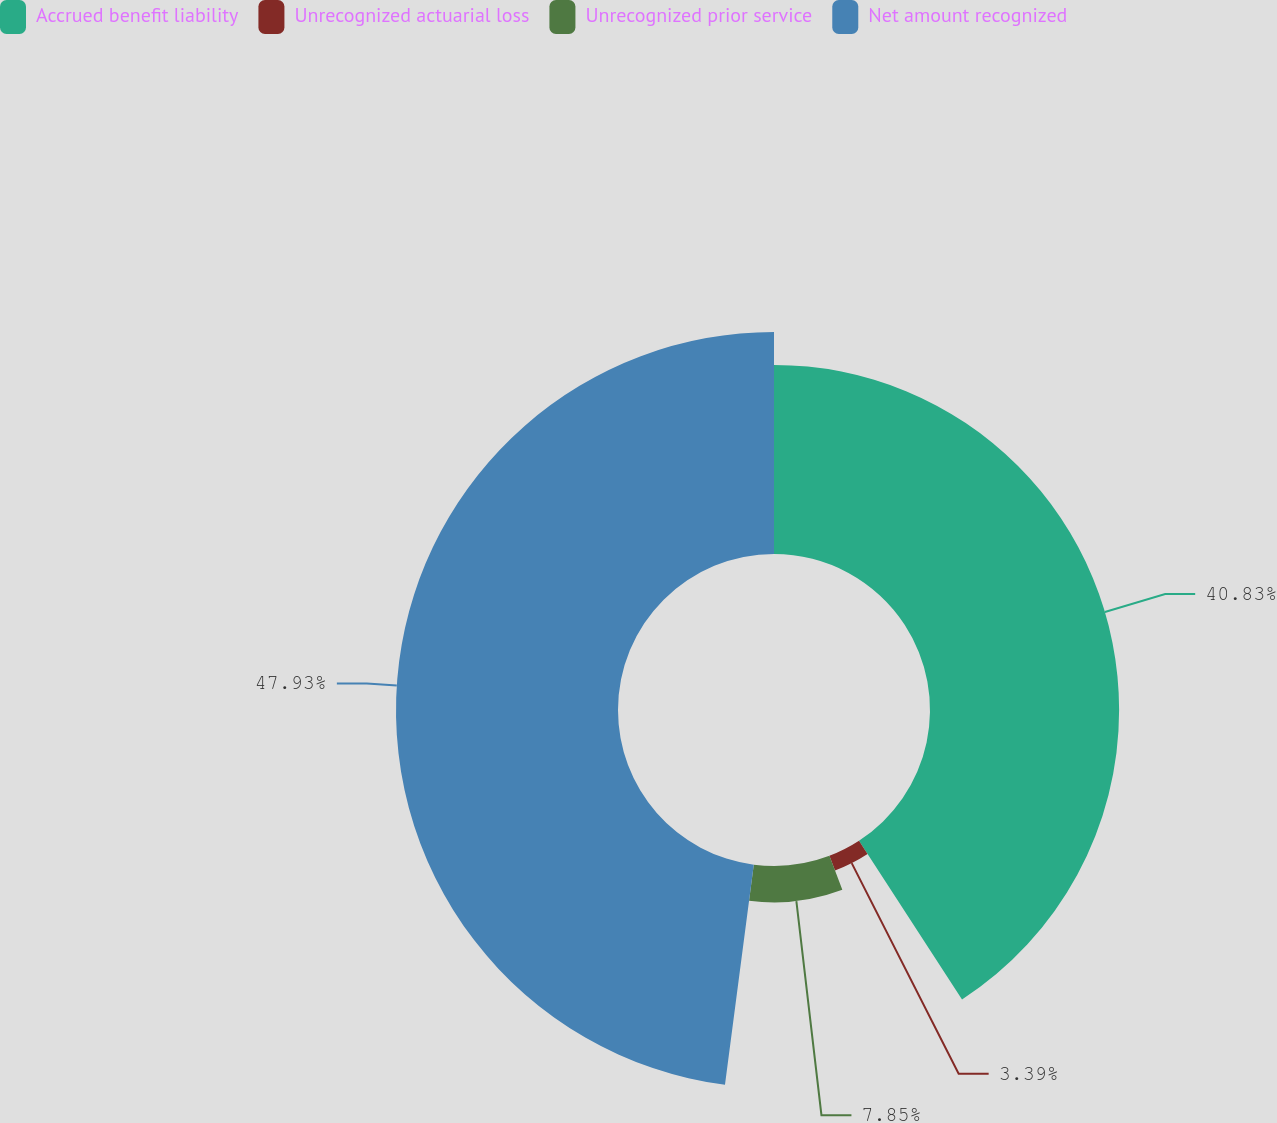Convert chart. <chart><loc_0><loc_0><loc_500><loc_500><pie_chart><fcel>Accrued benefit liability<fcel>Unrecognized actuarial loss<fcel>Unrecognized prior service<fcel>Net amount recognized<nl><fcel>40.83%<fcel>3.39%<fcel>7.85%<fcel>47.93%<nl></chart> 